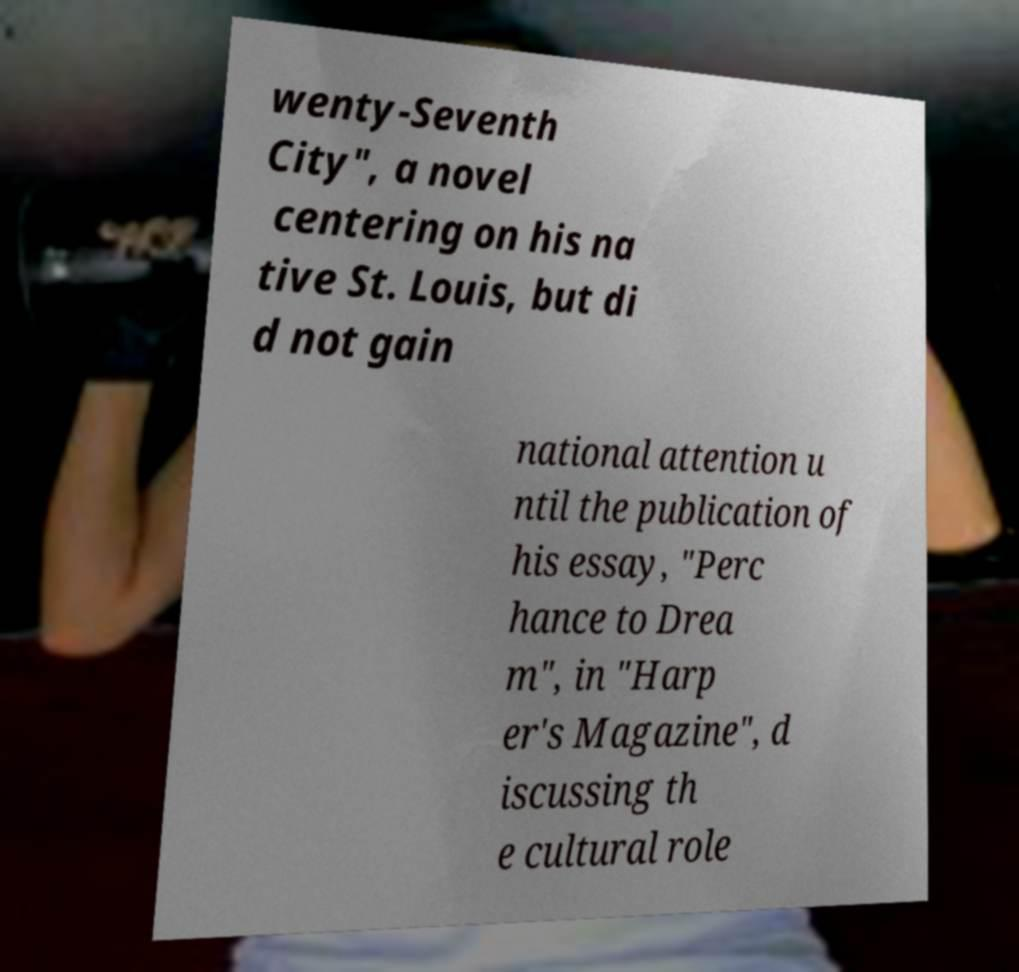What messages or text are displayed in this image? I need them in a readable, typed format. wenty-Seventh City", a novel centering on his na tive St. Louis, but di d not gain national attention u ntil the publication of his essay, "Perc hance to Drea m", in "Harp er's Magazine", d iscussing th e cultural role 